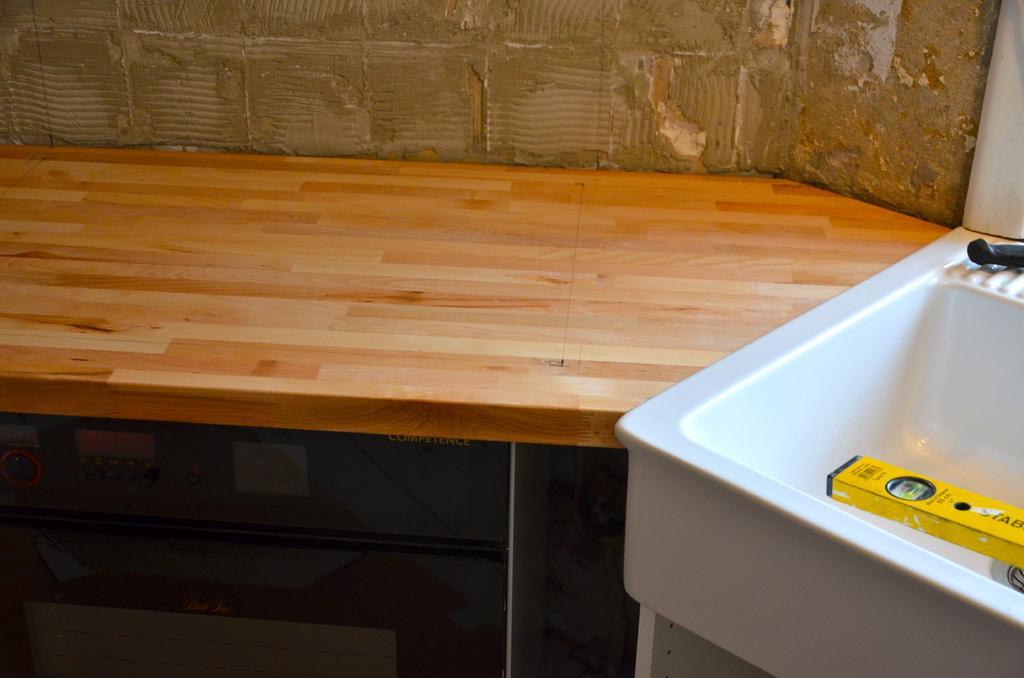Describe this image in one or two sentences. In this picture I can observe a brown color desk. On the right side I can observe white color sink. In the background there is a wall. 